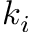<formula> <loc_0><loc_0><loc_500><loc_500>k _ { i }</formula> 